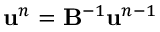Convert formula to latex. <formula><loc_0><loc_0><loc_500><loc_500>{ u } ^ { n } = B ^ { - 1 } { u } ^ { n - 1 }</formula> 